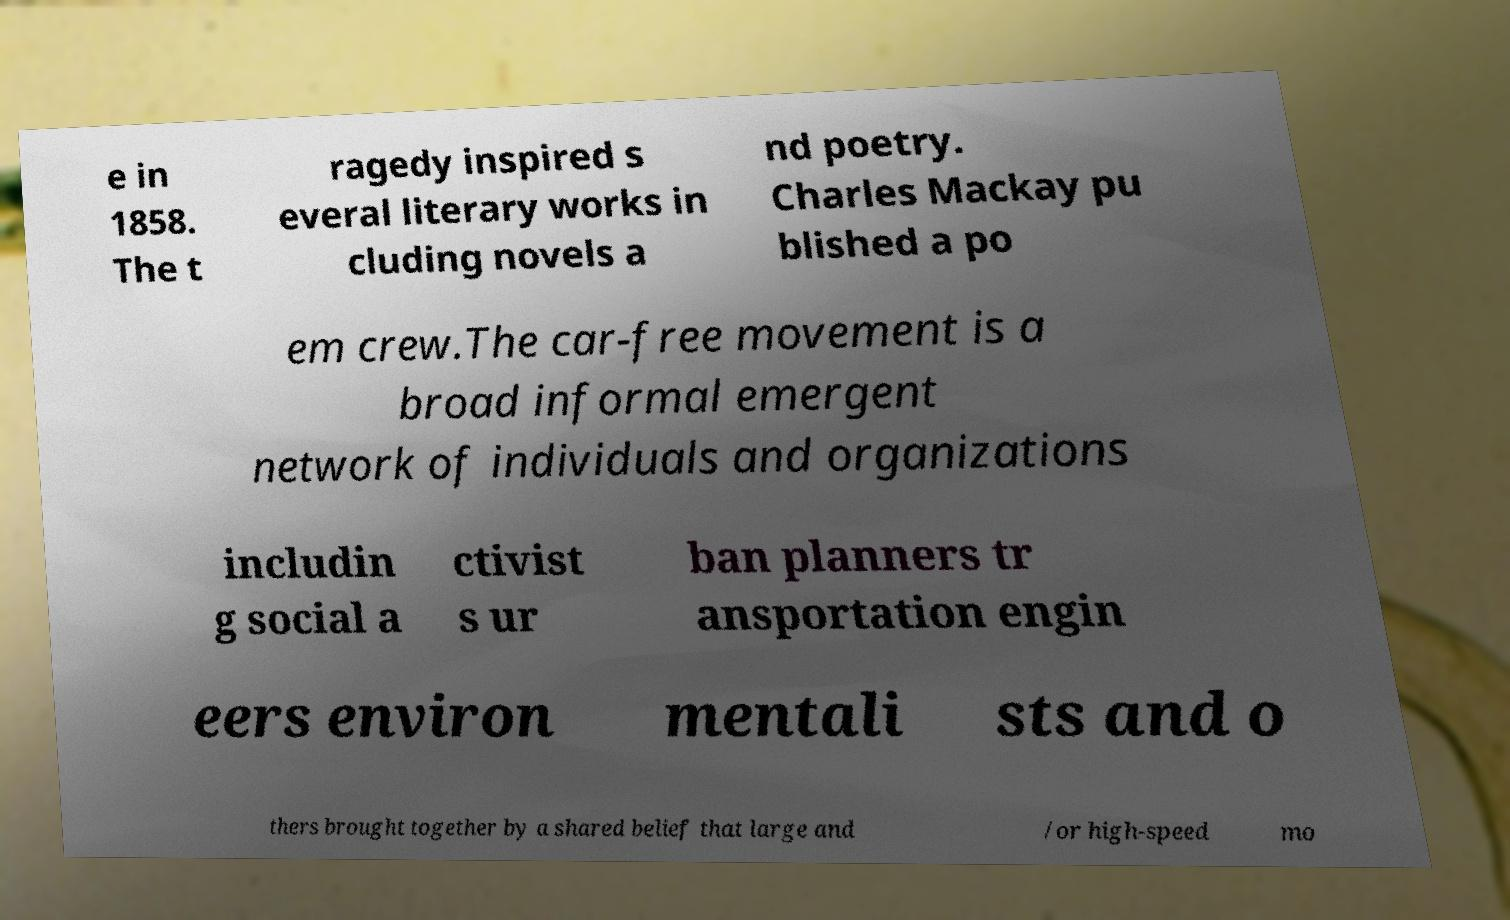For documentation purposes, I need the text within this image transcribed. Could you provide that? e in 1858. The t ragedy inspired s everal literary works in cluding novels a nd poetry. Charles Mackay pu blished a po em crew.The car-free movement is a broad informal emergent network of individuals and organizations includin g social a ctivist s ur ban planners tr ansportation engin eers environ mentali sts and o thers brought together by a shared belief that large and /or high-speed mo 